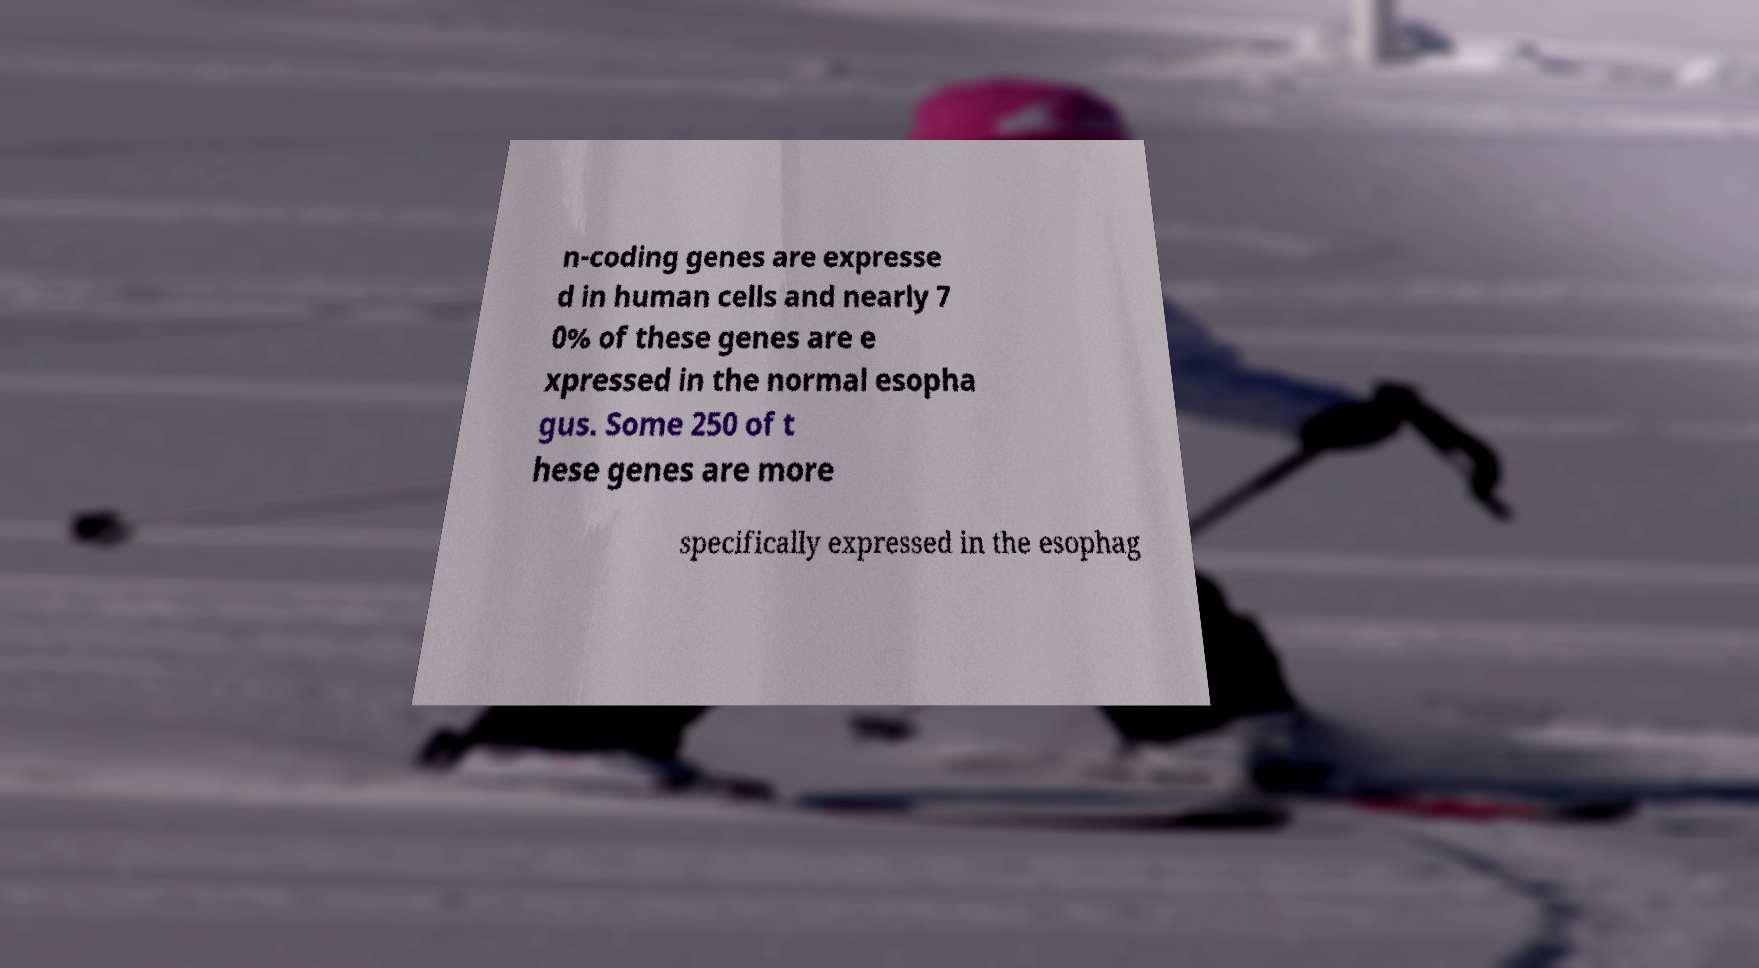There's text embedded in this image that I need extracted. Can you transcribe it verbatim? n-coding genes are expresse d in human cells and nearly 7 0% of these genes are e xpressed in the normal esopha gus. Some 250 of t hese genes are more specifically expressed in the esophag 